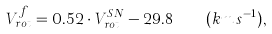<formula> <loc_0><loc_0><loc_500><loc_500>V _ { r o t } ^ { f } = 0 . 5 2 \cdot V _ { r o t } ^ { S N } - 2 9 . 8 \quad ( k m \, s ^ { - 1 } ) ,</formula> 